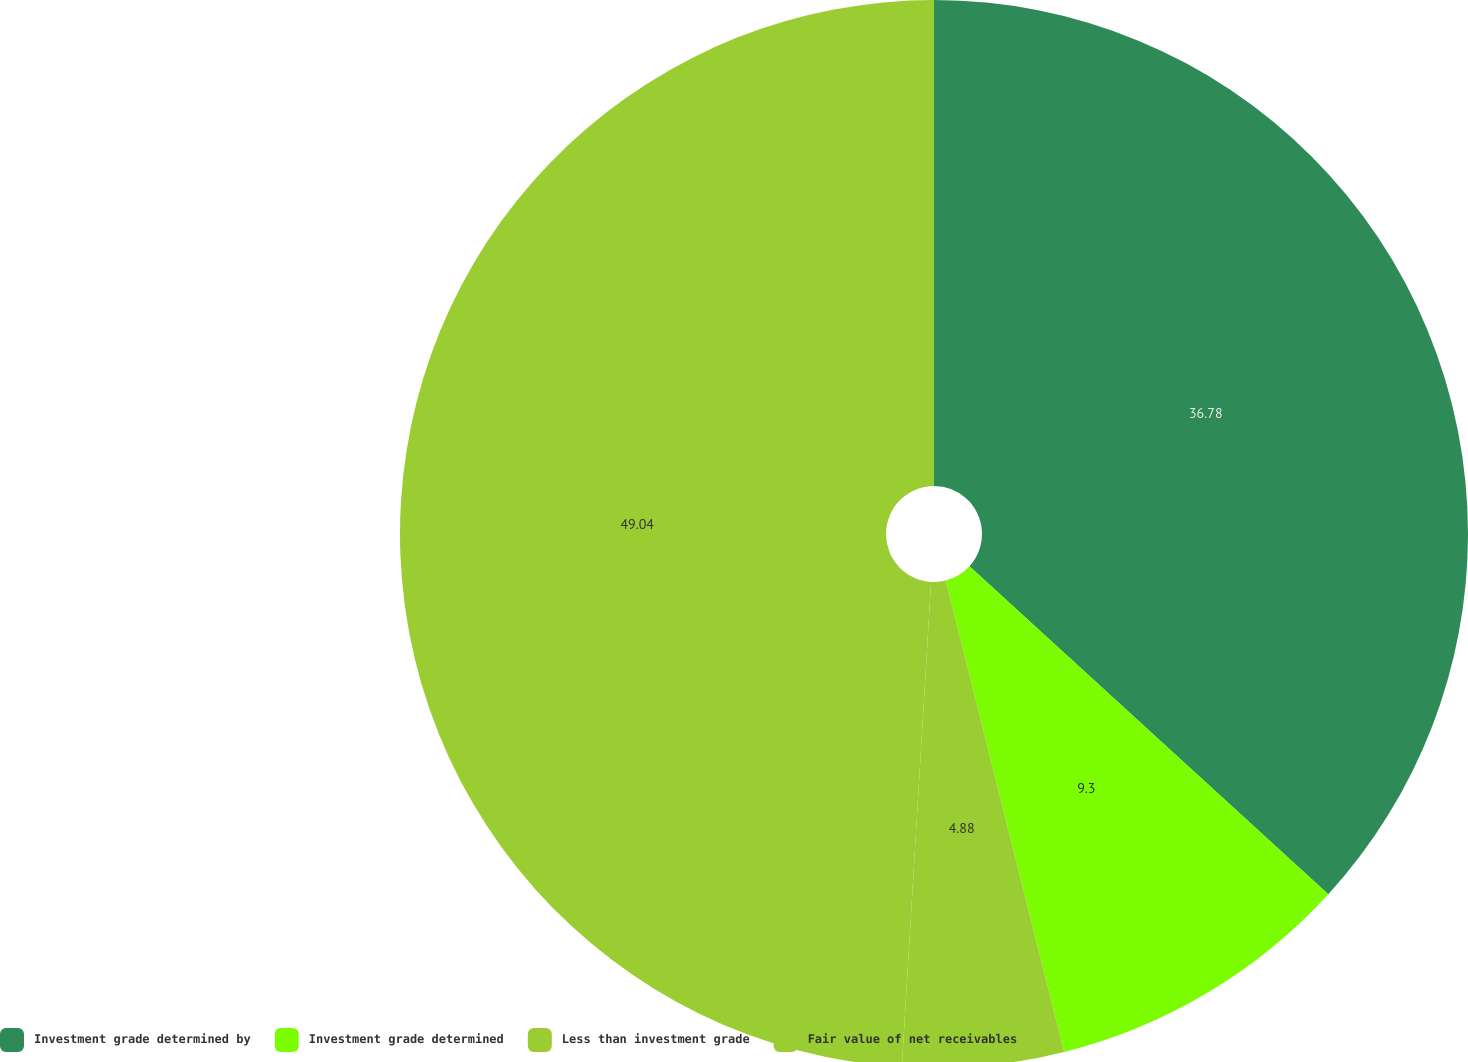Convert chart to OTSL. <chart><loc_0><loc_0><loc_500><loc_500><pie_chart><fcel>Investment grade determined by<fcel>Investment grade determined<fcel>Less than investment grade<fcel>Fair value of net receivables<nl><fcel>36.78%<fcel>9.3%<fcel>4.88%<fcel>49.04%<nl></chart> 